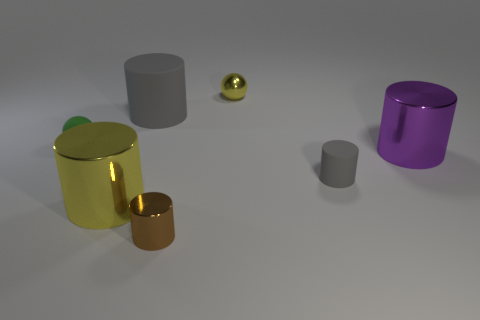What shape is the tiny yellow metallic thing? The tiny yellow object in the image appears to be a sphere, showcasing a metallic sheen that reflects the environment around it. 